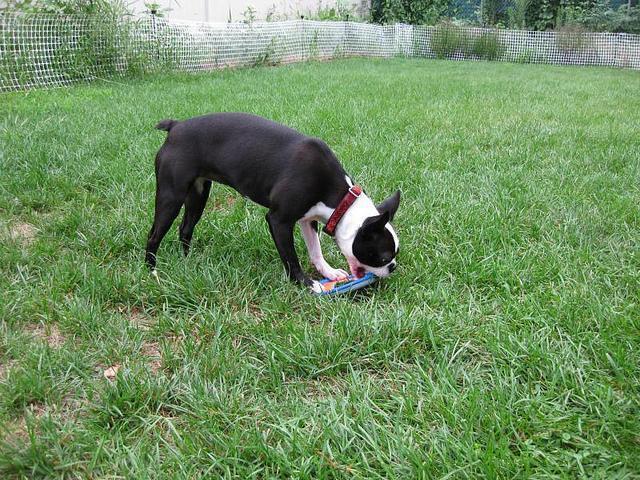How many men have no shirts on?
Give a very brief answer. 0. 